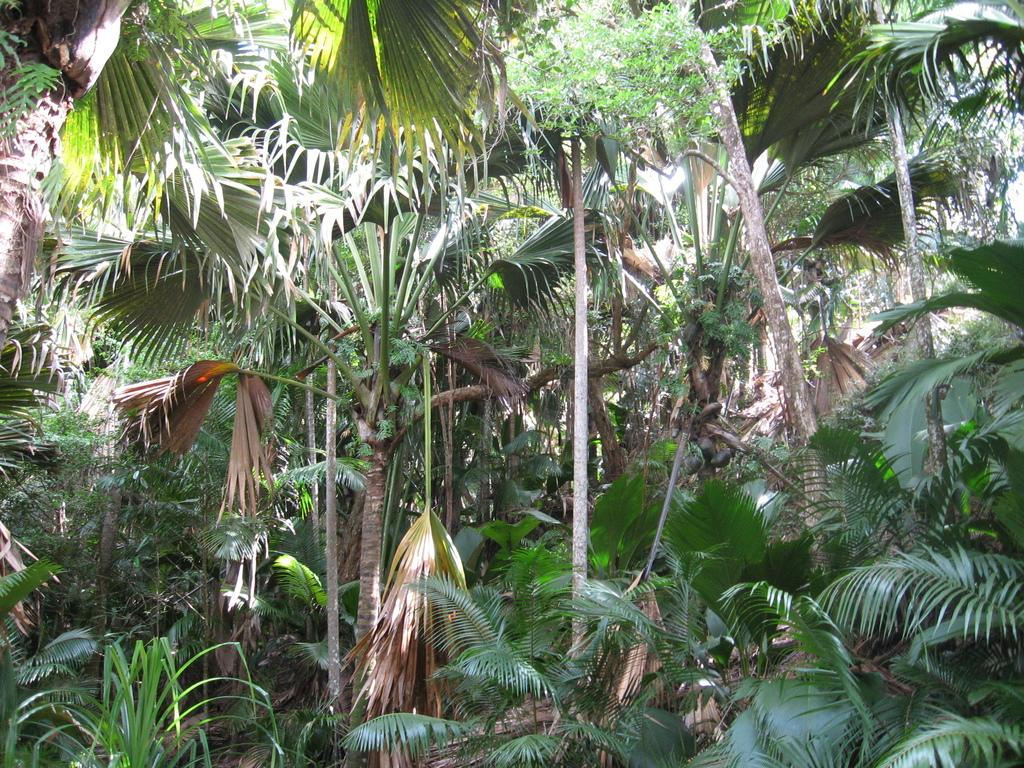What type of vegetation can be seen in the image? There are trees and plants in the image. Where are the trees and plants located? The trees and plants are on the land. Can you describe the smell of the dinosaurs in the image? There are no dinosaurs present in the image, so there is no smell to describe. 